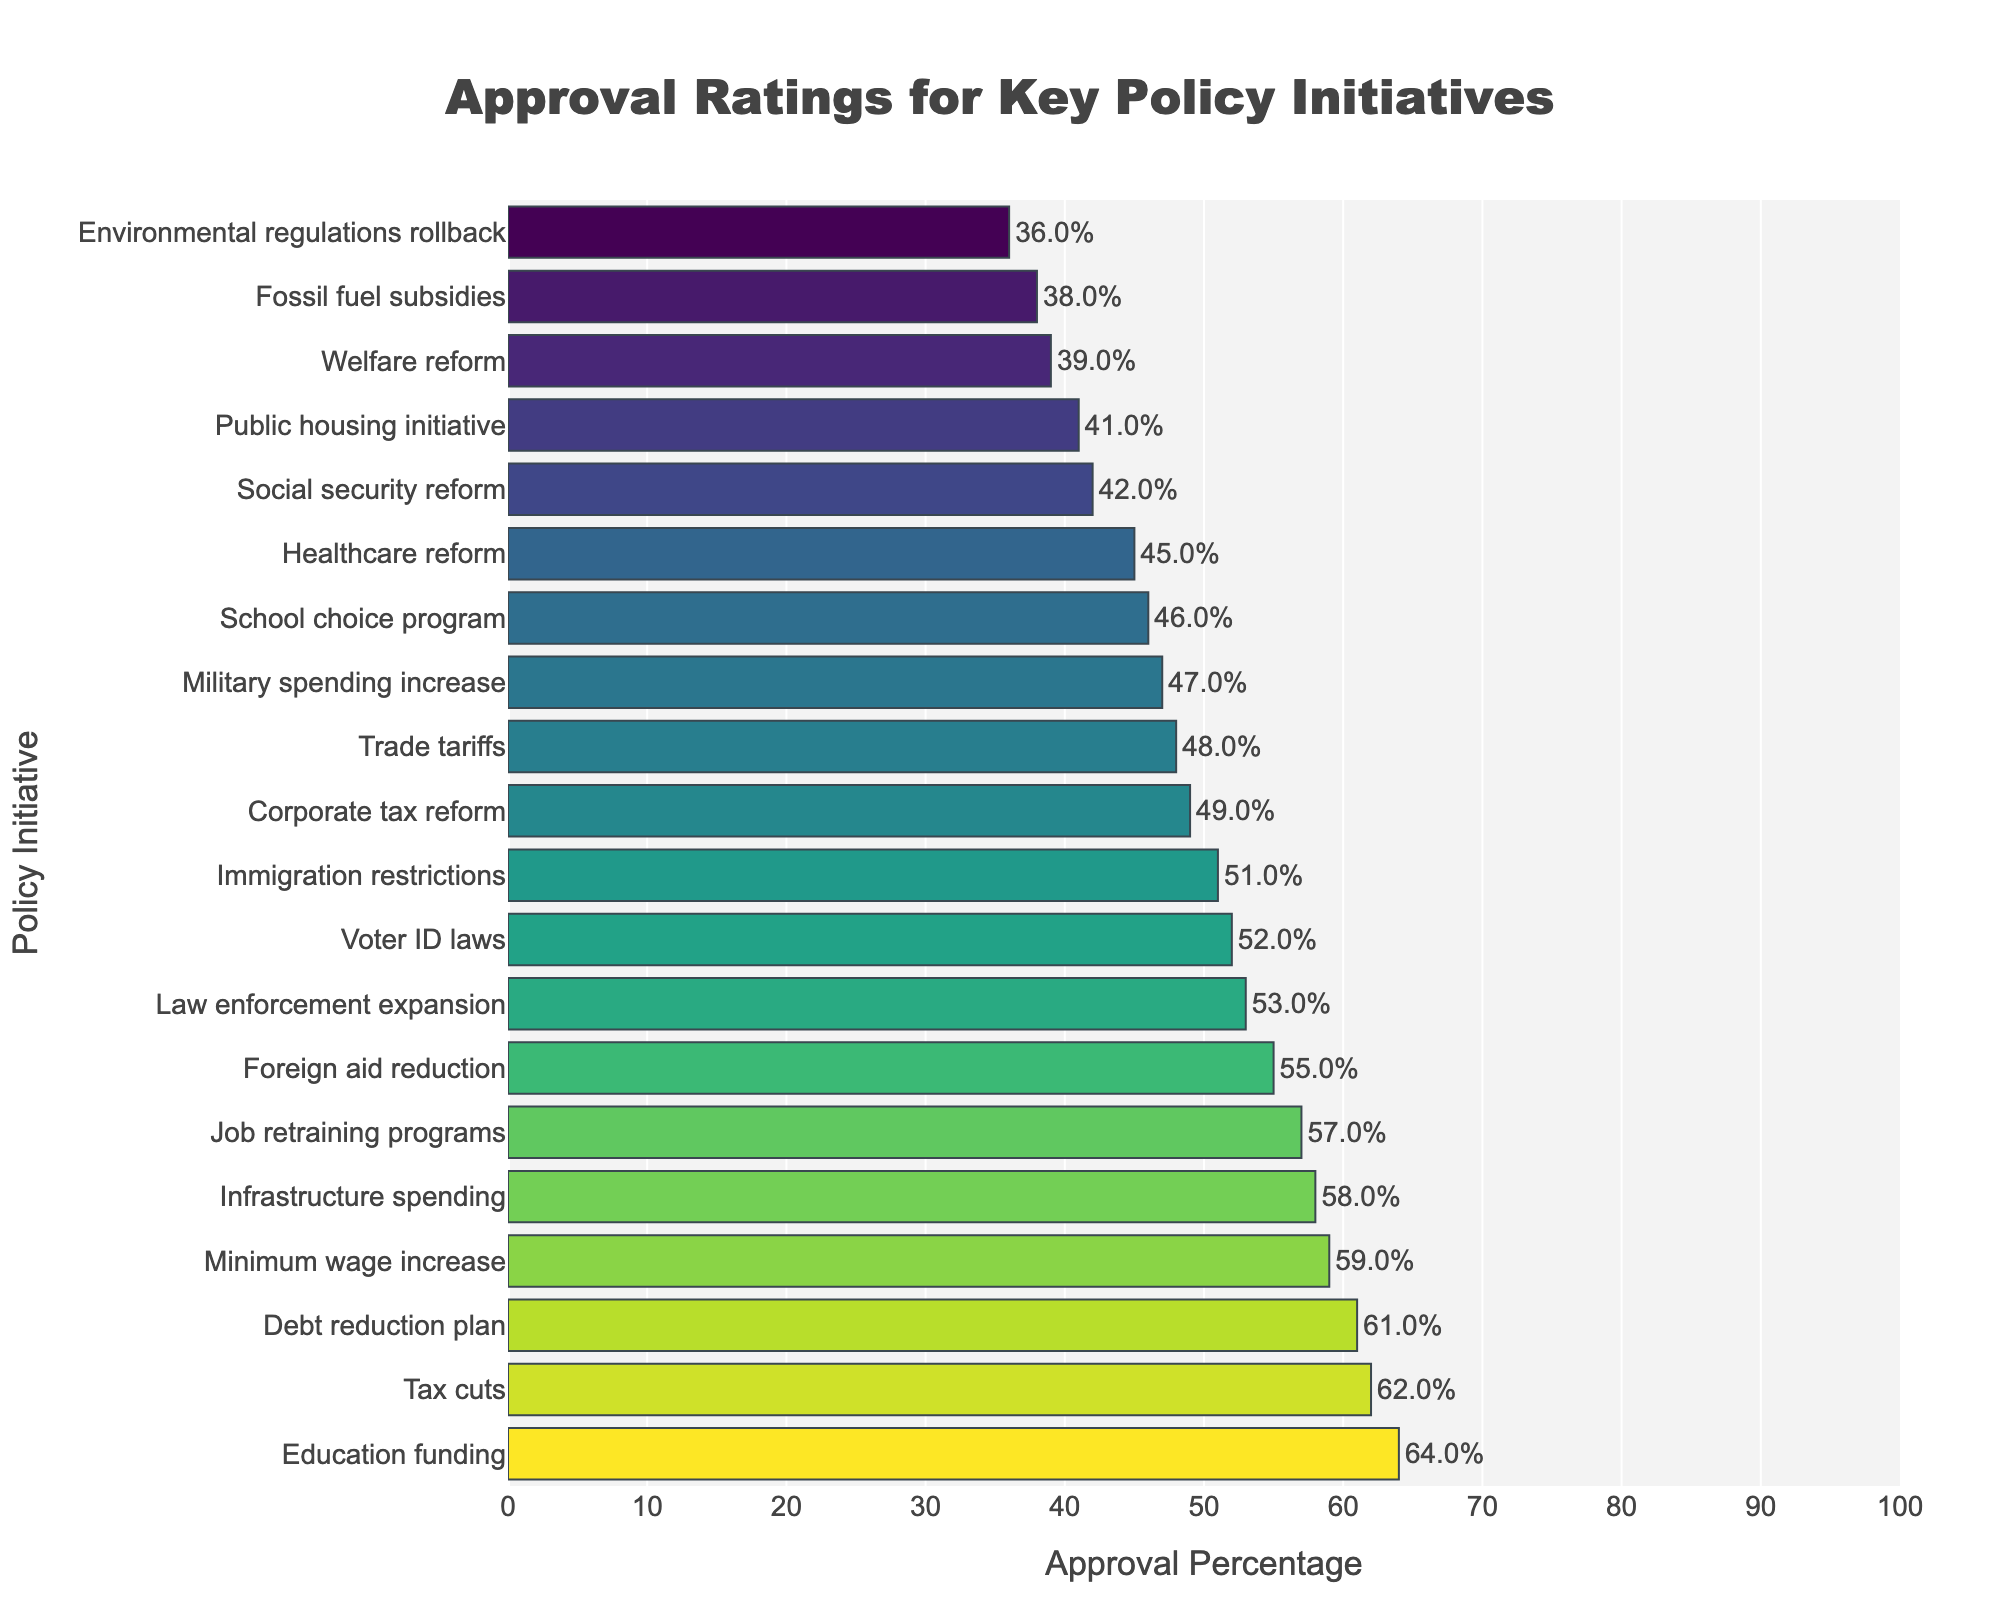what policy has the highest approval rating? Look at the y-axis labels and find the policy whose bar reaches the furthest on the x-axis towards 100%. This will be the policy with the highest approval.
Answer: Education funding Which two policies have similar approval ratings around 50%? Examine the bars that hover around the 50% mark on the x-axis. Identify the policies corresponding to these bars.
Answer: Law enforcement expansion and Immigration restrictions What is the combined approval percentage of Welfare reform and Social security reform? Find the bars for Welfare reform and Social security reform. Note their approval percentages (39% and 42% respectively) and add them together.
Answer: 81% What are the visual characteristics of the policy with the lowest approval rating? Look at the leftmost bar (shortest in length) and note its associated color and policy. The policy with the lowest rating will have the darkest shade as per the Viridis color scale.
Answer: Environmental regulations rollback; dark green Is the approval rating for Healthcare reform higher or lower than that for Trade tariffs? Locate the bars for Healthcare reform and Trade tariffs, then compare their lengths to see which is longer or higher up the x-axis.
Answer: Lower Which policy has the second highest approval rating, and what is the percentage? Identify the longest bar, then find the second longest bar. Note the policy associated and the percentage from the x-axis.
Answer: Tax cuts, 62% What is the average approval rating of Job retraining programs, Debt reduction plan, and Minimum wage increase? Extract the approval percentages for Job retraining programs (57%), Debt reduction plan (61%), and Minimum wage increase (59%). Calculate their average by summing the percentages and dividing by the number of policies (57 + 61 + 59) / 3.
Answer: 59% What is the percentage difference between Corporate tax reform and Public housing initiative? Find the approval ratings for Corporate tax reform (49%) and Public housing initiative (41%). Subtract the smaller percentage from the larger one to get the difference.
Answer: 8% Which policies have an approval rating equal to or greater than 60%? Identify all bars that extend to or beyond the 60% mark on the x-axis. Note the policies associated with these bars.
Answer: Education funding, Tax cuts, Debt reduction plan Are there more policies with approval ratings above 50% or below 50%? Count the number of bars that extend past the 50% mark, and compare to the number that do not.
Answer: Below 50% 